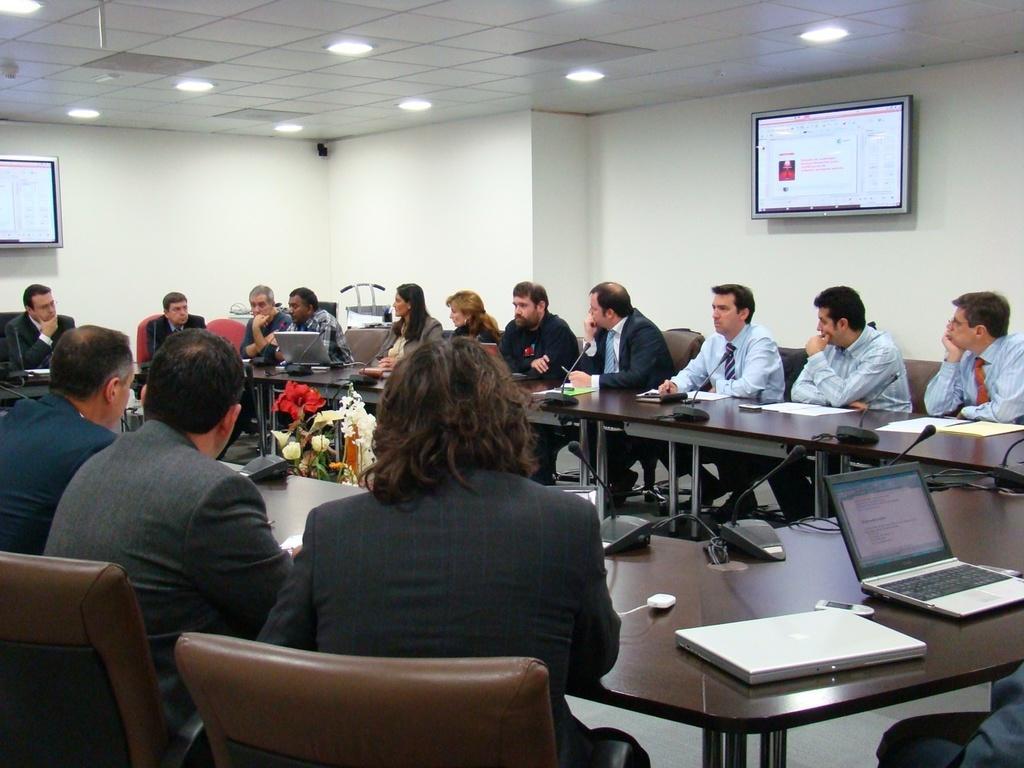Could you give a brief overview of what you see in this image? This is a conference room where the people are sitting on the chairs and behind them there are screens and in front of them there are desk on which there are some things like mike, laptop and between them there is a flower vase. 